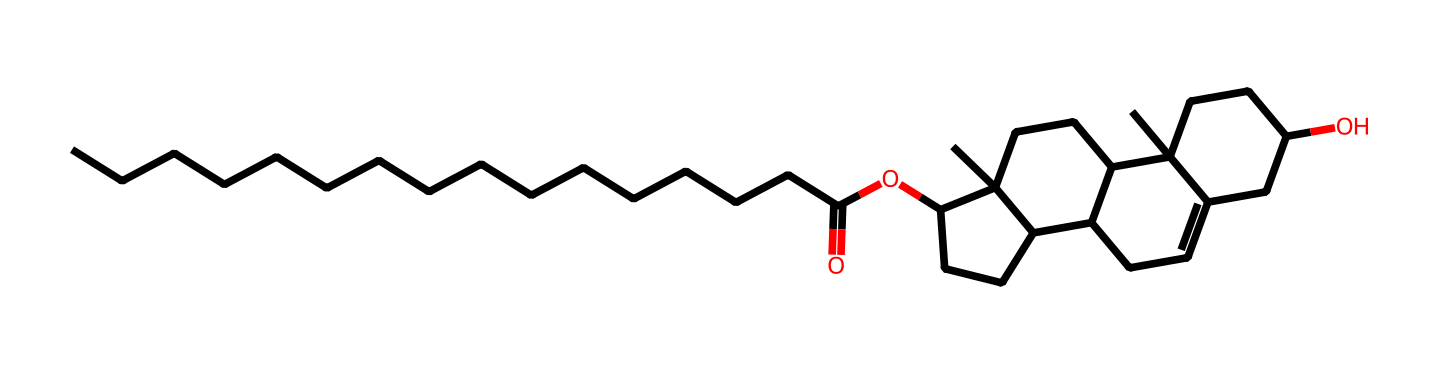What is the common name for this chemical? The molecule represented by the SMILES is lanolin, which is commonly found in hand creams and moisturizers. Lanolin is the natural wax secreted by the sebaceous glands of sheep and is used for its emollient properties.
Answer: lanolin How many carbon atoms are in this chemical? By examining the SMILES representation, we can count the number of carbon atoms (C), which appears multiple times throughout the structure. In total, there are 27 carbon atoms in the structure represented.
Answer: 27 What functional group is present in this chemical? The structure contains an ester linkage (O=C-O) which is characteristic of many natural oils and fats. This functional group is indicated by the carbonyl (C=O) attached to an oxygen.
Answer: ester Does this chemical contain any rings in its structure? Observing the SMILES, we see notation indicating multiple ring closure points (C1, C2, C3, C4). The molecule features several interconnected rings, confirming that it indeed contains cyclic structures.
Answer: yes What type of chemical is lanolin classified as? Lanolin is categorized specifically as a natural emollient due to its hydrating and skin-protecting properties. The presence of different hydrocarbons and esters gives it its classification as a lubricant and moisturization agent.
Answer: emollient Is this chemical hydrophilic or hydrophobic? The dominant long-chain carbon structures and ester functionality in lanolin suggest that it is primarily hydrophobic. This means it repels water and is better suited for forming protective barriers on the skin rather than dissolving in water.
Answer: hydrophobic 